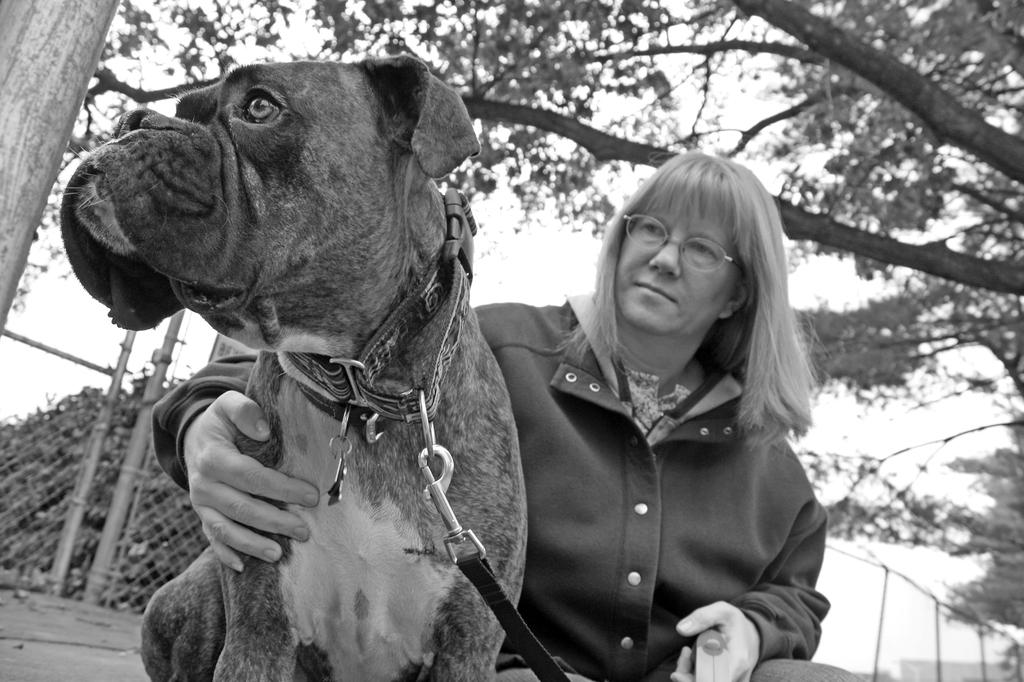What is the person in the image doing? The person is sitting in the image. What is the person holding in the image? The person is holding a dog in the image. What can be seen in the background of the image? There is a tree visible in the background of the image. What list of items can be seen on the seashore in the image? There is no seashore present in the image, and therefore no list of items can be seen. 